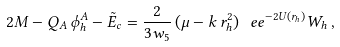<formula> <loc_0><loc_0><loc_500><loc_500>2 M - Q _ { A } \, \phi ^ { A } _ { h } - { \tilde { E } } _ { c } = \frac { 2 } { 3 w _ { 5 } } \, ( \mu - k \, r ^ { 2 } _ { h } ) \, \ e e ^ { - 2 U ( r _ { h } ) } W _ { h } \, ,</formula> 